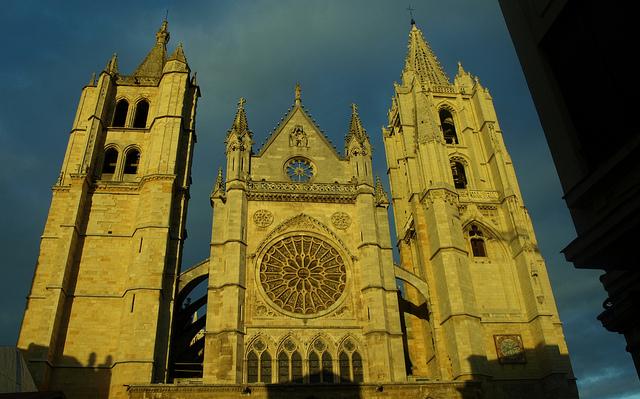How many windows can be seen on the facade of the cathedral?
Concise answer only. 7. Is this a church?
Answer briefly. Yes. Is this building made of stone?
Keep it brief. Yes. Is this a close up?
Answer briefly. No. How many windows are there?
Short answer required. 15. What two colors are the clock?
Quick response, please. Blue and tan. What is the building made of?
Concise answer only. Stone. 